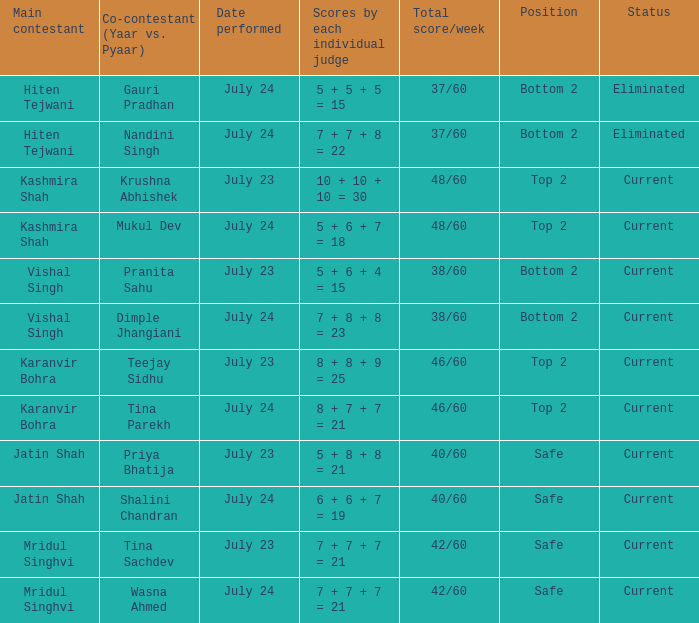Who is the main contestant with scores by each individual judge of 8 + 7 + 7 = 21? Karanvir Bohra. 